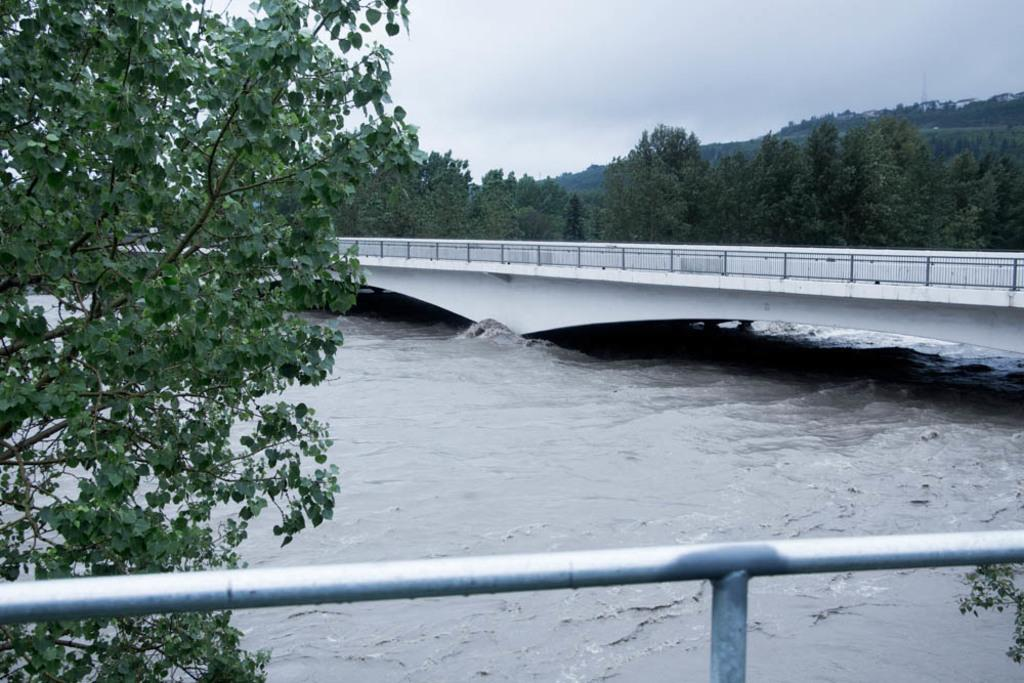What is located in the foreground of the image? There is a rod and a tree in the foreground of the image. What can be seen in the foreground of the image besides the rod and tree? There is water in the foreground of the image. What is visible in the background of the image? There is a bridge, trees, and clouds visible in the background of the image. What type of caption is written on the rod in the image? There is no caption written on the rod in the image. What punishment is being given to the trees in the background of the image? There is no punishment being given to the trees in the background of the image; they are simply standing there. 